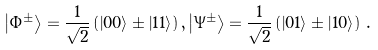<formula> <loc_0><loc_0><loc_500><loc_500>\left | \Phi ^ { \pm } \right \rangle = \frac { 1 } { \sqrt { 2 } } \left ( \left | 0 0 \right \rangle \pm \left | 1 1 \right \rangle \right ) , \left | \Psi ^ { \pm } \right \rangle = \frac { 1 } { \sqrt { 2 } } \left ( \left | 0 1 \right \rangle \pm \left | 1 0 \right \rangle \right ) \, .</formula> 